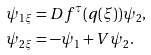<formula> <loc_0><loc_0><loc_500><loc_500>\psi _ { 1 \xi } & = D f ^ { \tau } ( q ( \xi ) ) \psi _ { 2 } , \\ \psi _ { 2 \xi } & = - \psi _ { 1 } + V \psi _ { 2 } .</formula> 